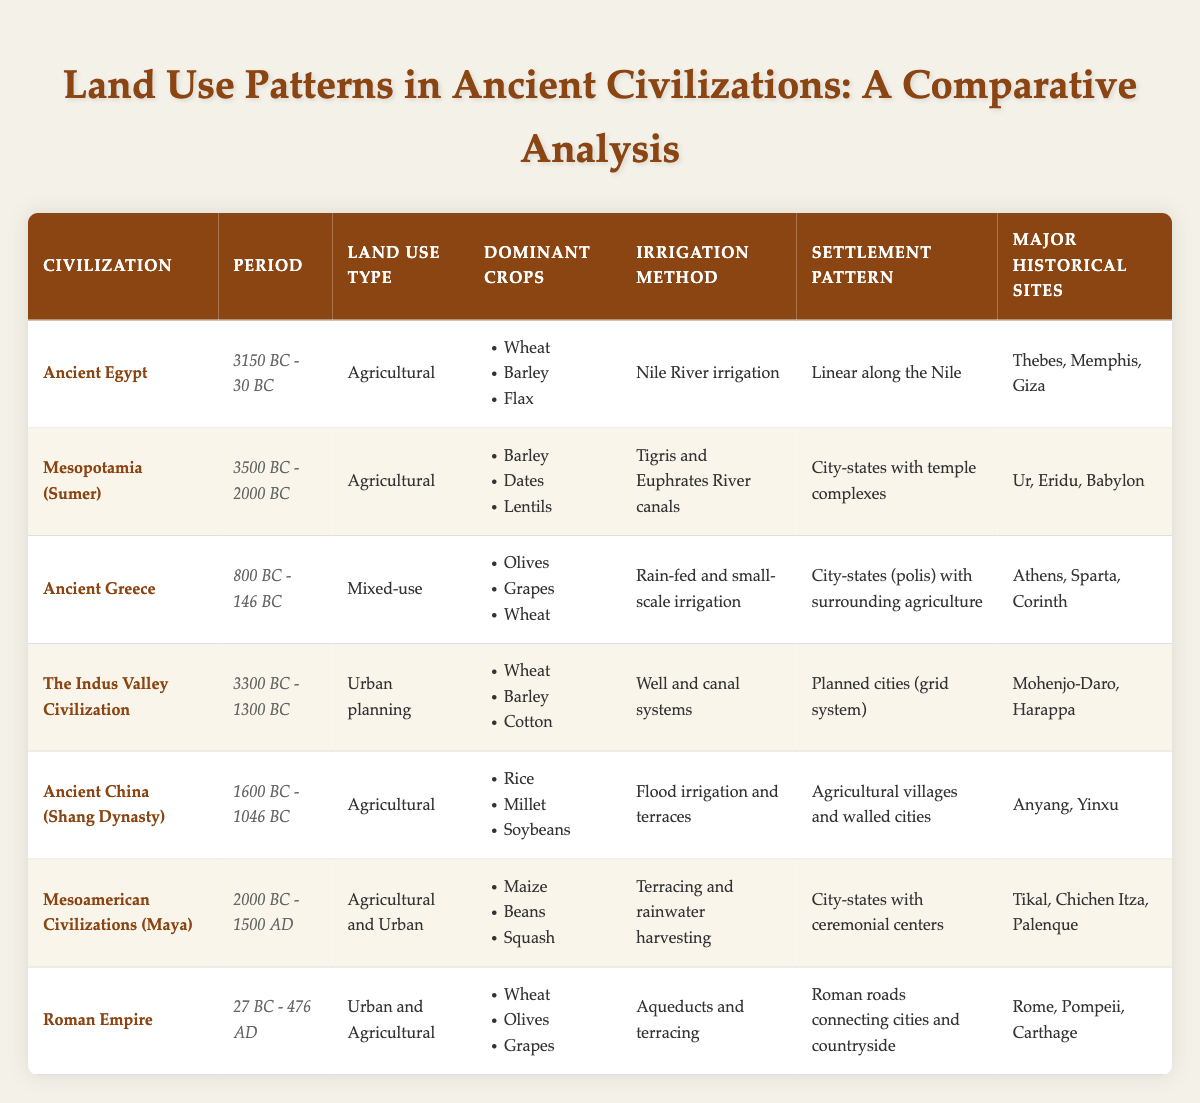What were the dominant crops in Ancient Egypt? Referring to the table, the dominant crops listed under Ancient Egypt are Wheat, Barley, and Flax.
Answer: Wheat, Barley, Flax Which civilization had a land use type classified as 'Urban planning'? The table indicates that The Indus Valley Civilization is classified under 'Urban planning' for its land use type.
Answer: The Indus Valley Civilization Did Mesopotamia (Sumer) use the Nile River for irrigation? The table states that Mesopotamia (Sumer) utilized Tigris and Euphrates River canals for irrigation, not the Nile River. Therefore, the answer is no.
Answer: No What is the settlement pattern for the Roman Empire? According to the table, the Roman Empire had a settlement pattern characterized by roads connecting cities and the countryside.
Answer: Roads connecting cities and countryside Which civilization had the earliest recorded period? By analyzing the table, Ancient Egypt had the earliest recorded period from 3150 BC - 30 BC, making it the earliest.
Answer: Ancient Egypt How many dominant crops does the Maya civilization have? The Maya civilization has three dominant crops listed: Maize, Beans, and Squash.
Answer: Three Are the major historical sites for Ancient Greece included in the table? The table lists major historical sites for Ancient Greece as Athens, Sparta, and Corinth, confirming their inclusion.
Answer: Yes For which civilization were aqueducts a method of irrigation? The table specifies that aqueducts and terracing were methods of irrigation used by the Roman Empire.
Answer: Roman Empire What method of irrigation is used by Ancient China (Shang Dynasty)? The table provides that Ancient China (Shang Dynasty) used flood irrigation and terraces for irrigation.
Answer: Flood irrigation and terraces Which civilization had a mixed-use land type? The table indicates that Ancient Greece is classified with a mixed-use land type.
Answer: Ancient Greece How does the period of the Mesoamerican Civilizations compare to the Roman Empire? The Mesoamerican Civilizations span from 2000 BC - 1500 AD, while the Roman Empire spans from 27 BC - 476 AD. Therefore, Mesoamerican Civilizations cover a broader time span, 3476 years, compared to the Roman Empire, which spans 503 years.
Answer: Mesoamerican Civilizations have a broader time span 